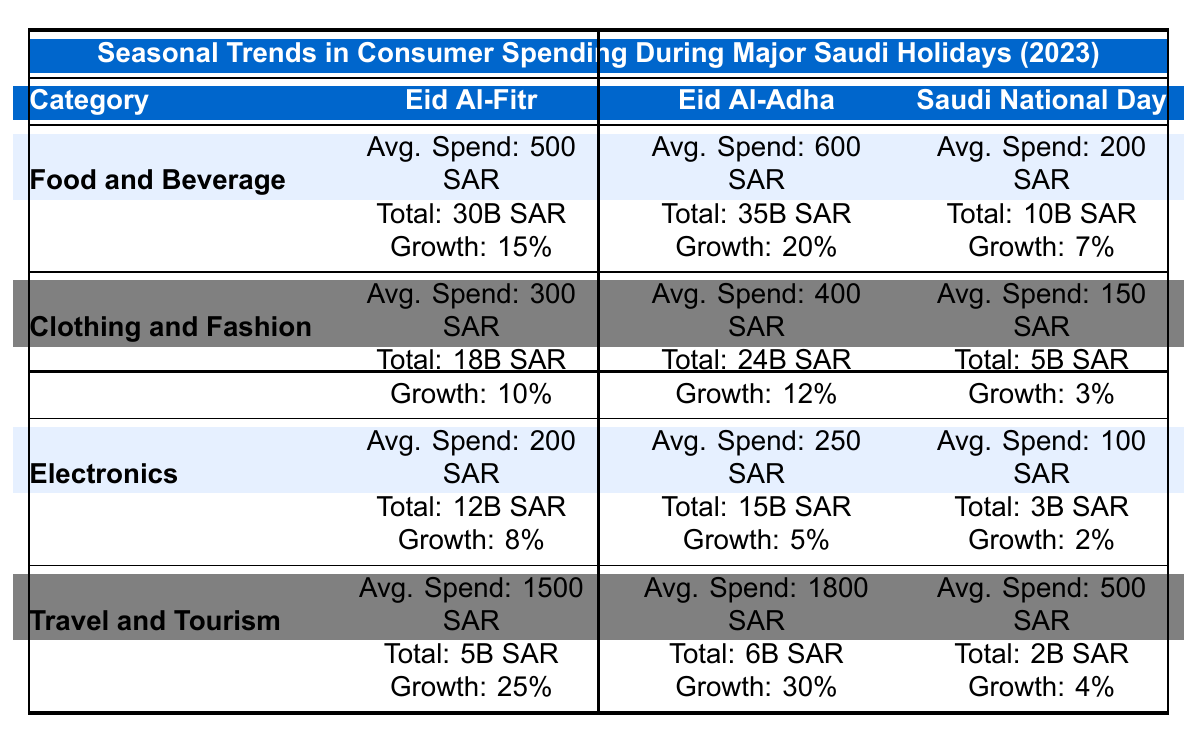What is the average spend per capita for Food and Beverage during Eid Al-Fitr? The average spend per capita for Food and Beverage is listed directly in the table for Eid Al-Fitr as 500 SAR.
Answer: 500 SAR What was the total spending in billions for Clothing and Fashion during Eid Al-Adha? The table indicates that the total spending for Clothing and Fashion during Eid Al-Adha is 24 billion SAR.
Answer: 24 billion SAR Which holiday had the highest growth rate in Travel and Tourism spending? By comparing the growth rates listed in the table, Eid Al-Adha has the highest growth rate at 30% for Travel and Tourism.
Answer: Eid Al-Adha What is the total spending in billions for Food and Beverage across all holidays? Summing the total spending for Food and Beverage: 30B (Eid Al-Fitr) + 35B (Eid Al-Adha) + 10B (Saudi National Day) gives us 75 billion SAR.
Answer: 75 billion SAR Did the average spend per capita for Electronics during Eid Al-Adha exceed 200 SAR? The average spend per capita for Electronics during Eid Al-Adha is 250 SAR, which is greater than 200 SAR.
Answer: Yes What is the difference in average spend per capita on Clothing and Fashion between Eid Al-Fitr and Saudi National Day? The average spend for Clothing and Fashion during Eid Al-Fitr is 300 SAR and for Saudi National Day is 150 SAR. The difference is 300 - 150 = 150 SAR.
Answer: 150 SAR What was the total spending for all categories during Saudi National Day? Adding the totals for all categories during Saudi National Day: 10B (Food) + 5B (Clothing) + 3B (Electronics) + 2B (Tourism) equals 20 billion SAR.
Answer: 20 billion SAR Which holiday had the lowest overall spending in a single category, and what was that amount? The lowest overall spending in a single category is 2 billion SAR for Travel and Tourism during Saudi National Day.
Answer: Saudi National Day, 2 billion SAR What percentage growth in average spend was observed in Food and Beverage from Eid Al-Fitr to Eid Al-Adha? To find the percentage growth: ((600 - 500) / 500) * 100 = 20%. Therefore, the growth rate for Food and Beverage is 20%.
Answer: 20% Calculate the average growth rate for Travel and Tourism across all three holidays. The growth rates for Travel and Tourism are 25% (Eid Al-Fitr), 30% (Eid Al-Adha), and 4% (Saudi National Day). The average is (25 + 30 + 4) / 3 = 19.67%.
Answer: 19.67% 